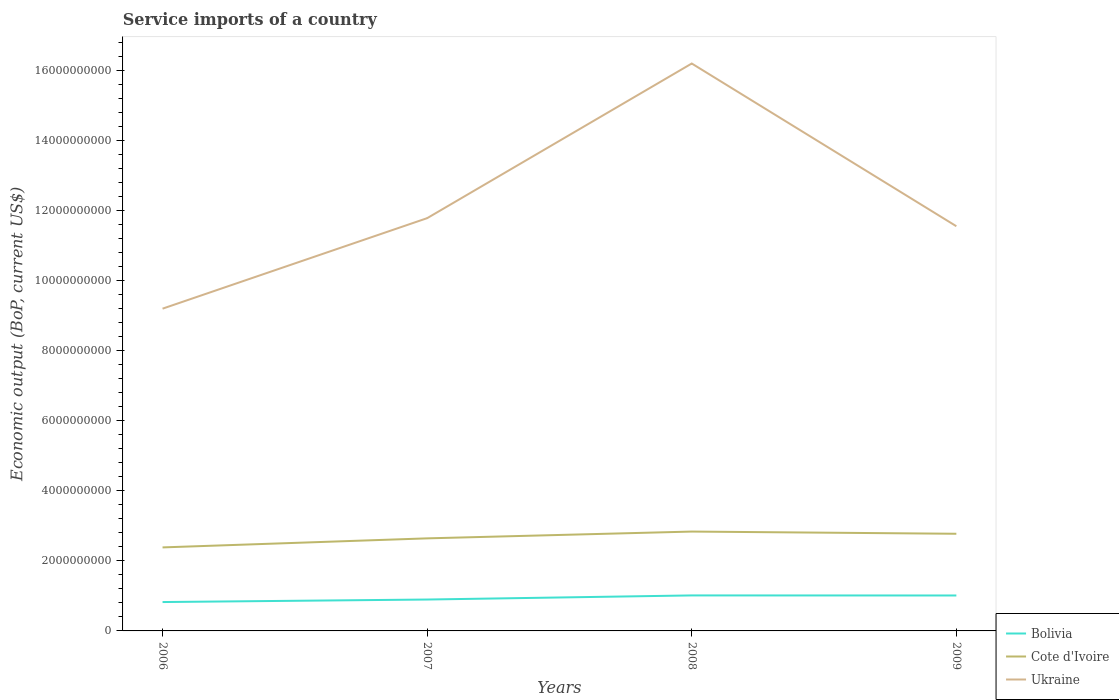Across all years, what is the maximum service imports in Bolivia?
Provide a short and direct response. 8.25e+08. What is the total service imports in Bolivia in the graph?
Your answer should be compact. 1.81e+06. What is the difference between the highest and the second highest service imports in Cote d'Ivoire?
Provide a short and direct response. 4.53e+08. What is the difference between the highest and the lowest service imports in Cote d'Ivoire?
Your answer should be compact. 2. How many years are there in the graph?
Give a very brief answer. 4. What is the difference between two consecutive major ticks on the Y-axis?
Make the answer very short. 2.00e+09. Does the graph contain any zero values?
Make the answer very short. No. Where does the legend appear in the graph?
Your answer should be compact. Bottom right. How many legend labels are there?
Provide a short and direct response. 3. How are the legend labels stacked?
Give a very brief answer. Vertical. What is the title of the graph?
Provide a succinct answer. Service imports of a country. What is the label or title of the X-axis?
Your answer should be compact. Years. What is the label or title of the Y-axis?
Make the answer very short. Economic output (BoP, current US$). What is the Economic output (BoP, current US$) of Bolivia in 2006?
Your response must be concise. 8.25e+08. What is the Economic output (BoP, current US$) of Cote d'Ivoire in 2006?
Your answer should be compact. 2.39e+09. What is the Economic output (BoP, current US$) of Ukraine in 2006?
Make the answer very short. 9.20e+09. What is the Economic output (BoP, current US$) of Bolivia in 2007?
Make the answer very short. 8.97e+08. What is the Economic output (BoP, current US$) in Cote d'Ivoire in 2007?
Your answer should be compact. 2.64e+09. What is the Economic output (BoP, current US$) in Ukraine in 2007?
Keep it short and to the point. 1.18e+1. What is the Economic output (BoP, current US$) of Bolivia in 2008?
Offer a very short reply. 1.01e+09. What is the Economic output (BoP, current US$) of Cote d'Ivoire in 2008?
Ensure brevity in your answer.  2.84e+09. What is the Economic output (BoP, current US$) in Ukraine in 2008?
Your response must be concise. 1.62e+1. What is the Economic output (BoP, current US$) of Bolivia in 2009?
Make the answer very short. 1.01e+09. What is the Economic output (BoP, current US$) of Cote d'Ivoire in 2009?
Your answer should be compact. 2.78e+09. What is the Economic output (BoP, current US$) in Ukraine in 2009?
Offer a very short reply. 1.16e+1. Across all years, what is the maximum Economic output (BoP, current US$) in Bolivia?
Your answer should be very brief. 1.01e+09. Across all years, what is the maximum Economic output (BoP, current US$) of Cote d'Ivoire?
Offer a terse response. 2.84e+09. Across all years, what is the maximum Economic output (BoP, current US$) of Ukraine?
Ensure brevity in your answer.  1.62e+1. Across all years, what is the minimum Economic output (BoP, current US$) in Bolivia?
Ensure brevity in your answer.  8.25e+08. Across all years, what is the minimum Economic output (BoP, current US$) of Cote d'Ivoire?
Offer a very short reply. 2.39e+09. Across all years, what is the minimum Economic output (BoP, current US$) of Ukraine?
Ensure brevity in your answer.  9.20e+09. What is the total Economic output (BoP, current US$) in Bolivia in the graph?
Provide a succinct answer. 3.75e+09. What is the total Economic output (BoP, current US$) of Cote d'Ivoire in the graph?
Your answer should be compact. 1.06e+1. What is the total Economic output (BoP, current US$) in Ukraine in the graph?
Ensure brevity in your answer.  4.88e+1. What is the difference between the Economic output (BoP, current US$) of Bolivia in 2006 and that in 2007?
Offer a terse response. -7.19e+07. What is the difference between the Economic output (BoP, current US$) in Cote d'Ivoire in 2006 and that in 2007?
Provide a short and direct response. -2.58e+08. What is the difference between the Economic output (BoP, current US$) in Ukraine in 2006 and that in 2007?
Ensure brevity in your answer.  -2.58e+09. What is the difference between the Economic output (BoP, current US$) in Bolivia in 2006 and that in 2008?
Your answer should be very brief. -1.89e+08. What is the difference between the Economic output (BoP, current US$) in Cote d'Ivoire in 2006 and that in 2008?
Give a very brief answer. -4.53e+08. What is the difference between the Economic output (BoP, current US$) of Ukraine in 2006 and that in 2008?
Provide a short and direct response. -7.00e+09. What is the difference between the Economic output (BoP, current US$) in Bolivia in 2006 and that in 2009?
Your answer should be very brief. -1.87e+08. What is the difference between the Economic output (BoP, current US$) in Cote d'Ivoire in 2006 and that in 2009?
Offer a very short reply. -3.90e+08. What is the difference between the Economic output (BoP, current US$) of Ukraine in 2006 and that in 2009?
Your response must be concise. -2.36e+09. What is the difference between the Economic output (BoP, current US$) in Bolivia in 2007 and that in 2008?
Give a very brief answer. -1.17e+08. What is the difference between the Economic output (BoP, current US$) of Cote d'Ivoire in 2007 and that in 2008?
Give a very brief answer. -1.94e+08. What is the difference between the Economic output (BoP, current US$) of Ukraine in 2007 and that in 2008?
Provide a short and direct response. -4.42e+09. What is the difference between the Economic output (BoP, current US$) in Bolivia in 2007 and that in 2009?
Make the answer very short. -1.15e+08. What is the difference between the Economic output (BoP, current US$) of Cote d'Ivoire in 2007 and that in 2009?
Offer a terse response. -1.31e+08. What is the difference between the Economic output (BoP, current US$) of Ukraine in 2007 and that in 2009?
Provide a succinct answer. 2.30e+08. What is the difference between the Economic output (BoP, current US$) in Bolivia in 2008 and that in 2009?
Offer a terse response. 1.81e+06. What is the difference between the Economic output (BoP, current US$) in Cote d'Ivoire in 2008 and that in 2009?
Your answer should be very brief. 6.32e+07. What is the difference between the Economic output (BoP, current US$) in Ukraine in 2008 and that in 2009?
Your response must be concise. 4.65e+09. What is the difference between the Economic output (BoP, current US$) of Bolivia in 2006 and the Economic output (BoP, current US$) of Cote d'Ivoire in 2007?
Make the answer very short. -1.82e+09. What is the difference between the Economic output (BoP, current US$) in Bolivia in 2006 and the Economic output (BoP, current US$) in Ukraine in 2007?
Your answer should be very brief. -1.10e+1. What is the difference between the Economic output (BoP, current US$) in Cote d'Ivoire in 2006 and the Economic output (BoP, current US$) in Ukraine in 2007?
Your answer should be compact. -9.40e+09. What is the difference between the Economic output (BoP, current US$) in Bolivia in 2006 and the Economic output (BoP, current US$) in Cote d'Ivoire in 2008?
Give a very brief answer. -2.01e+09. What is the difference between the Economic output (BoP, current US$) of Bolivia in 2006 and the Economic output (BoP, current US$) of Ukraine in 2008?
Provide a short and direct response. -1.54e+1. What is the difference between the Economic output (BoP, current US$) in Cote d'Ivoire in 2006 and the Economic output (BoP, current US$) in Ukraine in 2008?
Make the answer very short. -1.38e+1. What is the difference between the Economic output (BoP, current US$) of Bolivia in 2006 and the Economic output (BoP, current US$) of Cote d'Ivoire in 2009?
Provide a succinct answer. -1.95e+09. What is the difference between the Economic output (BoP, current US$) of Bolivia in 2006 and the Economic output (BoP, current US$) of Ukraine in 2009?
Make the answer very short. -1.07e+1. What is the difference between the Economic output (BoP, current US$) in Cote d'Ivoire in 2006 and the Economic output (BoP, current US$) in Ukraine in 2009?
Your response must be concise. -9.17e+09. What is the difference between the Economic output (BoP, current US$) in Bolivia in 2007 and the Economic output (BoP, current US$) in Cote d'Ivoire in 2008?
Provide a short and direct response. -1.94e+09. What is the difference between the Economic output (BoP, current US$) in Bolivia in 2007 and the Economic output (BoP, current US$) in Ukraine in 2008?
Provide a succinct answer. -1.53e+1. What is the difference between the Economic output (BoP, current US$) in Cote d'Ivoire in 2007 and the Economic output (BoP, current US$) in Ukraine in 2008?
Your answer should be compact. -1.36e+1. What is the difference between the Economic output (BoP, current US$) in Bolivia in 2007 and the Economic output (BoP, current US$) in Cote d'Ivoire in 2009?
Provide a short and direct response. -1.88e+09. What is the difference between the Economic output (BoP, current US$) in Bolivia in 2007 and the Economic output (BoP, current US$) in Ukraine in 2009?
Give a very brief answer. -1.07e+1. What is the difference between the Economic output (BoP, current US$) in Cote d'Ivoire in 2007 and the Economic output (BoP, current US$) in Ukraine in 2009?
Make the answer very short. -8.92e+09. What is the difference between the Economic output (BoP, current US$) of Bolivia in 2008 and the Economic output (BoP, current US$) of Cote d'Ivoire in 2009?
Provide a short and direct response. -1.76e+09. What is the difference between the Economic output (BoP, current US$) in Bolivia in 2008 and the Economic output (BoP, current US$) in Ukraine in 2009?
Give a very brief answer. -1.05e+1. What is the difference between the Economic output (BoP, current US$) in Cote d'Ivoire in 2008 and the Economic output (BoP, current US$) in Ukraine in 2009?
Ensure brevity in your answer.  -8.72e+09. What is the average Economic output (BoP, current US$) in Bolivia per year?
Keep it short and to the point. 9.37e+08. What is the average Economic output (BoP, current US$) of Cote d'Ivoire per year?
Your answer should be compact. 2.66e+09. What is the average Economic output (BoP, current US$) in Ukraine per year?
Your response must be concise. 1.22e+1. In the year 2006, what is the difference between the Economic output (BoP, current US$) in Bolivia and Economic output (BoP, current US$) in Cote d'Ivoire?
Your answer should be compact. -1.56e+09. In the year 2006, what is the difference between the Economic output (BoP, current US$) of Bolivia and Economic output (BoP, current US$) of Ukraine?
Provide a succinct answer. -8.38e+09. In the year 2006, what is the difference between the Economic output (BoP, current US$) of Cote d'Ivoire and Economic output (BoP, current US$) of Ukraine?
Provide a succinct answer. -6.82e+09. In the year 2007, what is the difference between the Economic output (BoP, current US$) in Bolivia and Economic output (BoP, current US$) in Cote d'Ivoire?
Your answer should be very brief. -1.75e+09. In the year 2007, what is the difference between the Economic output (BoP, current US$) of Bolivia and Economic output (BoP, current US$) of Ukraine?
Make the answer very short. -1.09e+1. In the year 2007, what is the difference between the Economic output (BoP, current US$) of Cote d'Ivoire and Economic output (BoP, current US$) of Ukraine?
Give a very brief answer. -9.15e+09. In the year 2008, what is the difference between the Economic output (BoP, current US$) of Bolivia and Economic output (BoP, current US$) of Cote d'Ivoire?
Offer a terse response. -1.82e+09. In the year 2008, what is the difference between the Economic output (BoP, current US$) of Bolivia and Economic output (BoP, current US$) of Ukraine?
Offer a terse response. -1.52e+1. In the year 2008, what is the difference between the Economic output (BoP, current US$) of Cote d'Ivoire and Economic output (BoP, current US$) of Ukraine?
Provide a short and direct response. -1.34e+1. In the year 2009, what is the difference between the Economic output (BoP, current US$) of Bolivia and Economic output (BoP, current US$) of Cote d'Ivoire?
Provide a short and direct response. -1.76e+09. In the year 2009, what is the difference between the Economic output (BoP, current US$) in Bolivia and Economic output (BoP, current US$) in Ukraine?
Provide a short and direct response. -1.05e+1. In the year 2009, what is the difference between the Economic output (BoP, current US$) of Cote d'Ivoire and Economic output (BoP, current US$) of Ukraine?
Ensure brevity in your answer.  -8.78e+09. What is the ratio of the Economic output (BoP, current US$) in Bolivia in 2006 to that in 2007?
Offer a terse response. 0.92. What is the ratio of the Economic output (BoP, current US$) of Cote d'Ivoire in 2006 to that in 2007?
Your answer should be very brief. 0.9. What is the ratio of the Economic output (BoP, current US$) in Ukraine in 2006 to that in 2007?
Your answer should be compact. 0.78. What is the ratio of the Economic output (BoP, current US$) of Bolivia in 2006 to that in 2008?
Offer a very short reply. 0.81. What is the ratio of the Economic output (BoP, current US$) of Cote d'Ivoire in 2006 to that in 2008?
Offer a terse response. 0.84. What is the ratio of the Economic output (BoP, current US$) of Ukraine in 2006 to that in 2008?
Your response must be concise. 0.57. What is the ratio of the Economic output (BoP, current US$) of Bolivia in 2006 to that in 2009?
Make the answer very short. 0.81. What is the ratio of the Economic output (BoP, current US$) of Cote d'Ivoire in 2006 to that in 2009?
Provide a succinct answer. 0.86. What is the ratio of the Economic output (BoP, current US$) in Ukraine in 2006 to that in 2009?
Provide a short and direct response. 0.8. What is the ratio of the Economic output (BoP, current US$) of Bolivia in 2007 to that in 2008?
Keep it short and to the point. 0.88. What is the ratio of the Economic output (BoP, current US$) of Cote d'Ivoire in 2007 to that in 2008?
Give a very brief answer. 0.93. What is the ratio of the Economic output (BoP, current US$) of Ukraine in 2007 to that in 2008?
Your answer should be compact. 0.73. What is the ratio of the Economic output (BoP, current US$) in Bolivia in 2007 to that in 2009?
Give a very brief answer. 0.89. What is the ratio of the Economic output (BoP, current US$) of Cote d'Ivoire in 2007 to that in 2009?
Offer a terse response. 0.95. What is the ratio of the Economic output (BoP, current US$) of Ukraine in 2007 to that in 2009?
Offer a terse response. 1.02. What is the ratio of the Economic output (BoP, current US$) in Cote d'Ivoire in 2008 to that in 2009?
Keep it short and to the point. 1.02. What is the ratio of the Economic output (BoP, current US$) in Ukraine in 2008 to that in 2009?
Keep it short and to the point. 1.4. What is the difference between the highest and the second highest Economic output (BoP, current US$) of Bolivia?
Offer a very short reply. 1.81e+06. What is the difference between the highest and the second highest Economic output (BoP, current US$) of Cote d'Ivoire?
Give a very brief answer. 6.32e+07. What is the difference between the highest and the second highest Economic output (BoP, current US$) of Ukraine?
Make the answer very short. 4.42e+09. What is the difference between the highest and the lowest Economic output (BoP, current US$) in Bolivia?
Your answer should be very brief. 1.89e+08. What is the difference between the highest and the lowest Economic output (BoP, current US$) in Cote d'Ivoire?
Offer a very short reply. 4.53e+08. What is the difference between the highest and the lowest Economic output (BoP, current US$) in Ukraine?
Offer a terse response. 7.00e+09. 